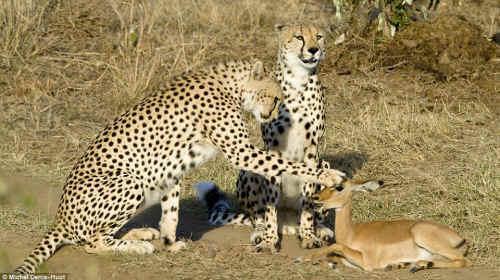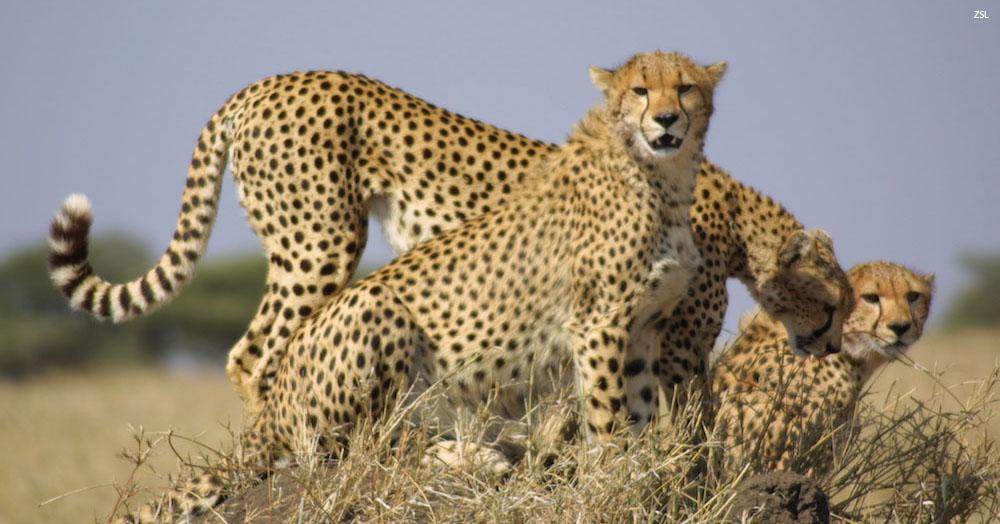The first image is the image on the left, the second image is the image on the right. Evaluate the accuracy of this statement regarding the images: "In one image, there are three cheetahs sitting on their haunches, and in the other image, there are at least three cheetahs lying down.". Is it true? Answer yes or no. No. The first image is the image on the left, the second image is the image on the right. Given the left and right images, does the statement "in the left image cheetahs are laying on a mound of dirt" hold true? Answer yes or no. No. 